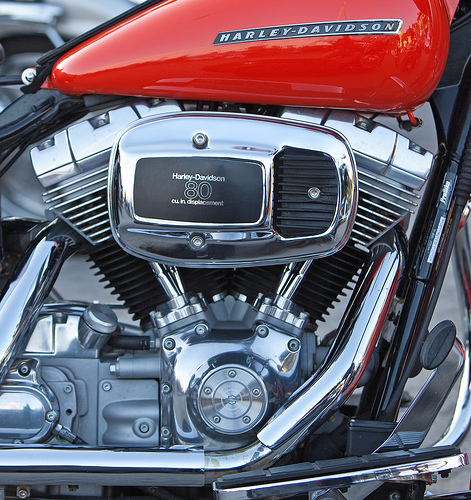<image>
Can you confirm if the engine is in the muffler? No. The engine is not contained within the muffler. These objects have a different spatial relationship. 